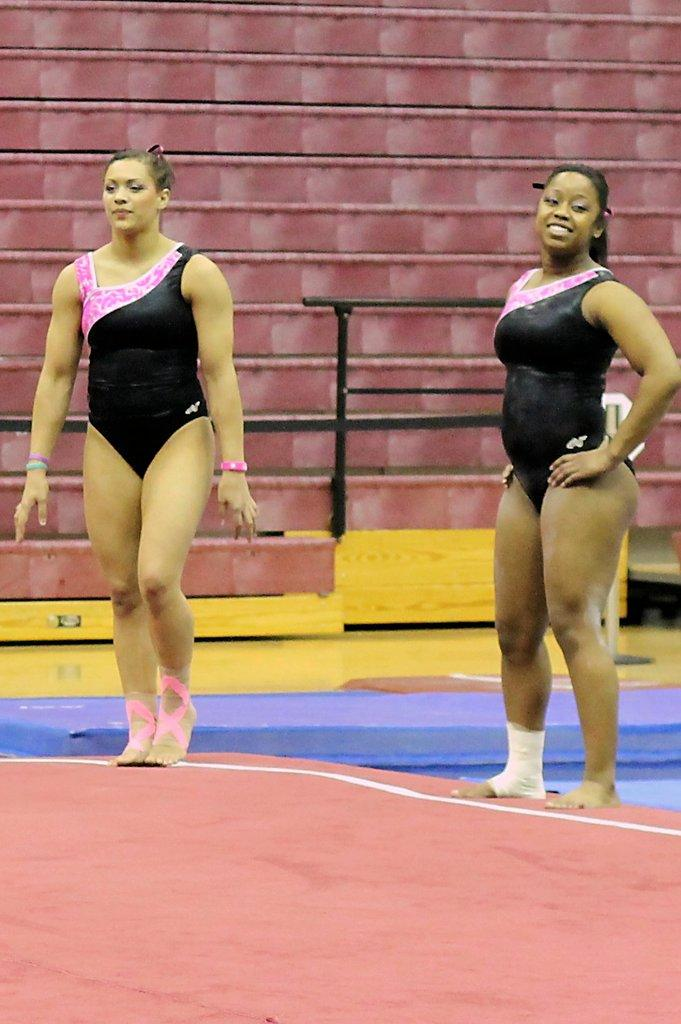How many people are in the image? There are two people in the image. What are the people wearing? Both people are wearing black tops. What activity are the people engaged in? The two people are doing gymnastics. What can be seen in the background of the image? There is a red-colored frame in the background of the image. What things can be seen in the park in the image? There is no park present in the image; it features two people doing gymnastics with a red-colored frame in the background. 